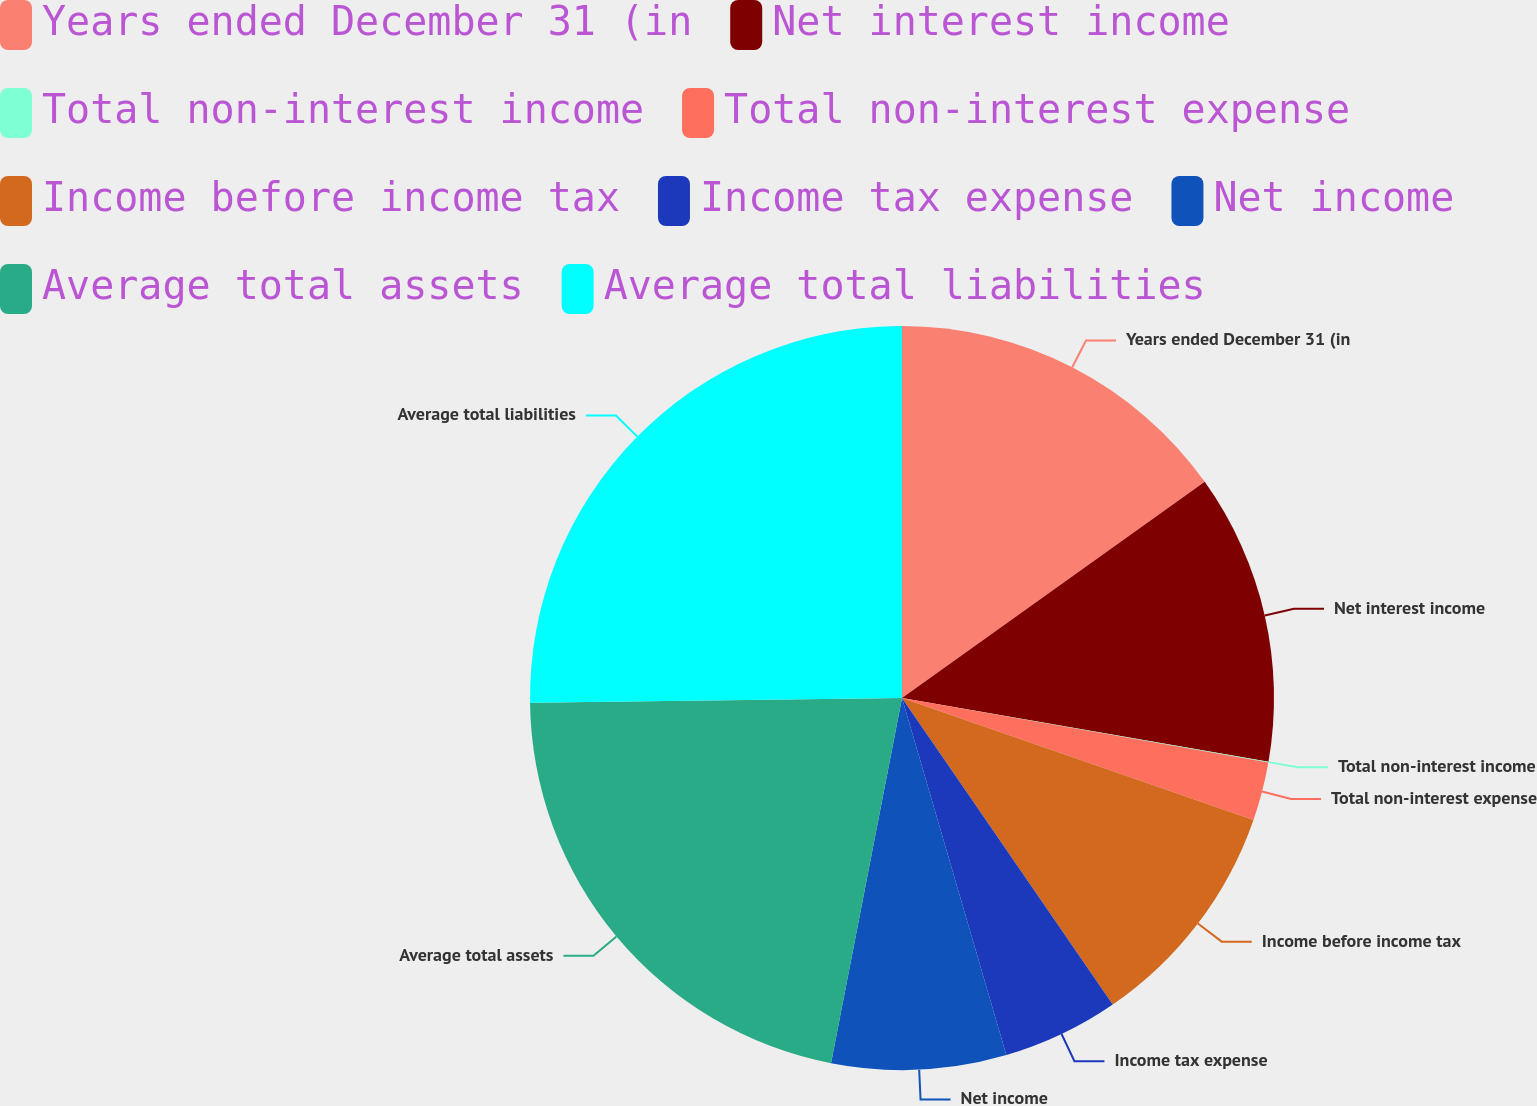Convert chart to OTSL. <chart><loc_0><loc_0><loc_500><loc_500><pie_chart><fcel>Years ended December 31 (in<fcel>Net interest income<fcel>Total non-interest income<fcel>Total non-interest expense<fcel>Income before income tax<fcel>Income tax expense<fcel>Net income<fcel>Average total assets<fcel>Average total liabilities<nl><fcel>15.13%<fcel>12.61%<fcel>0.03%<fcel>2.54%<fcel>10.1%<fcel>5.06%<fcel>7.58%<fcel>21.74%<fcel>25.2%<nl></chart> 